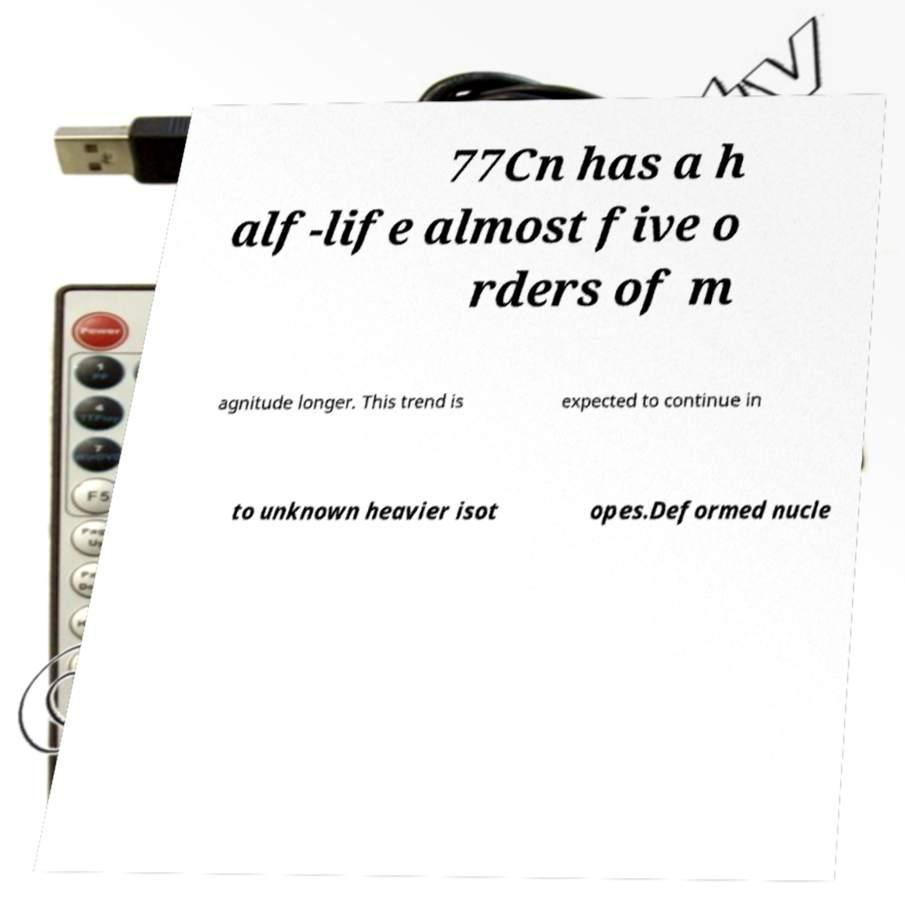Could you extract and type out the text from this image? 77Cn has a h alf-life almost five o rders of m agnitude longer. This trend is expected to continue in to unknown heavier isot opes.Deformed nucle 